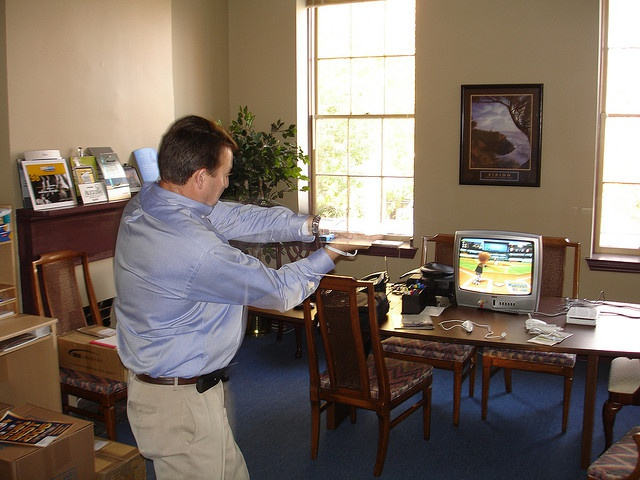Describe the objects in this image and their specific colors. I can see people in maroon, darkgray, gray, and black tones, chair in maroon and black tones, dining table in maroon, black, white, and gray tones, chair in maroon, black, and brown tones, and tv in maroon, ivory, gray, khaki, and darkgray tones in this image. 